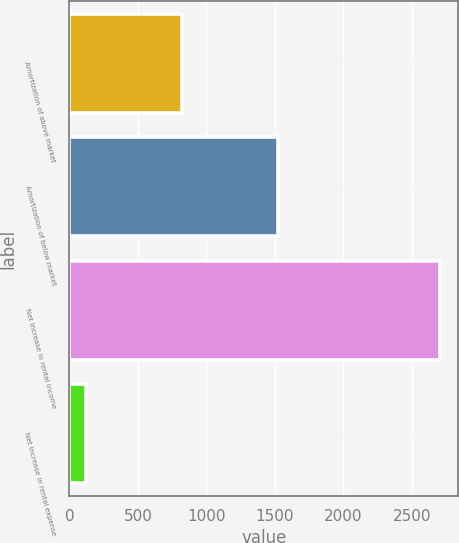Convert chart. <chart><loc_0><loc_0><loc_500><loc_500><bar_chart><fcel>Amortization of above market<fcel>Amortization of below market<fcel>Net increase in rental income<fcel>Net increase in rental expense<nl><fcel>821<fcel>1522<fcel>2705<fcel>120<nl></chart> 